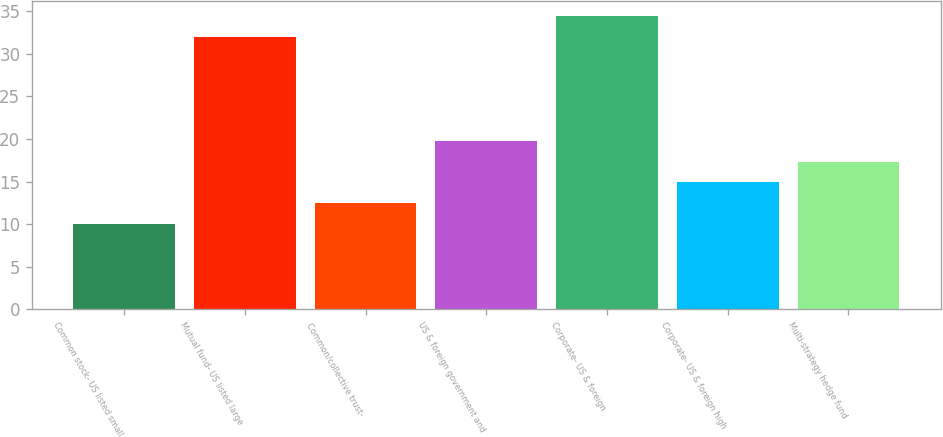Convert chart to OTSL. <chart><loc_0><loc_0><loc_500><loc_500><bar_chart><fcel>Common stock- US listed small<fcel>Mutual fund- US listed large<fcel>Common/collective trust-<fcel>US & foreign government and<fcel>Corporate- US & foreign<fcel>Corporate- US & foreign high<fcel>Multi-strategy hedge fund<nl><fcel>10<fcel>32<fcel>12.45<fcel>19.8<fcel>34.5<fcel>14.9<fcel>17.35<nl></chart> 